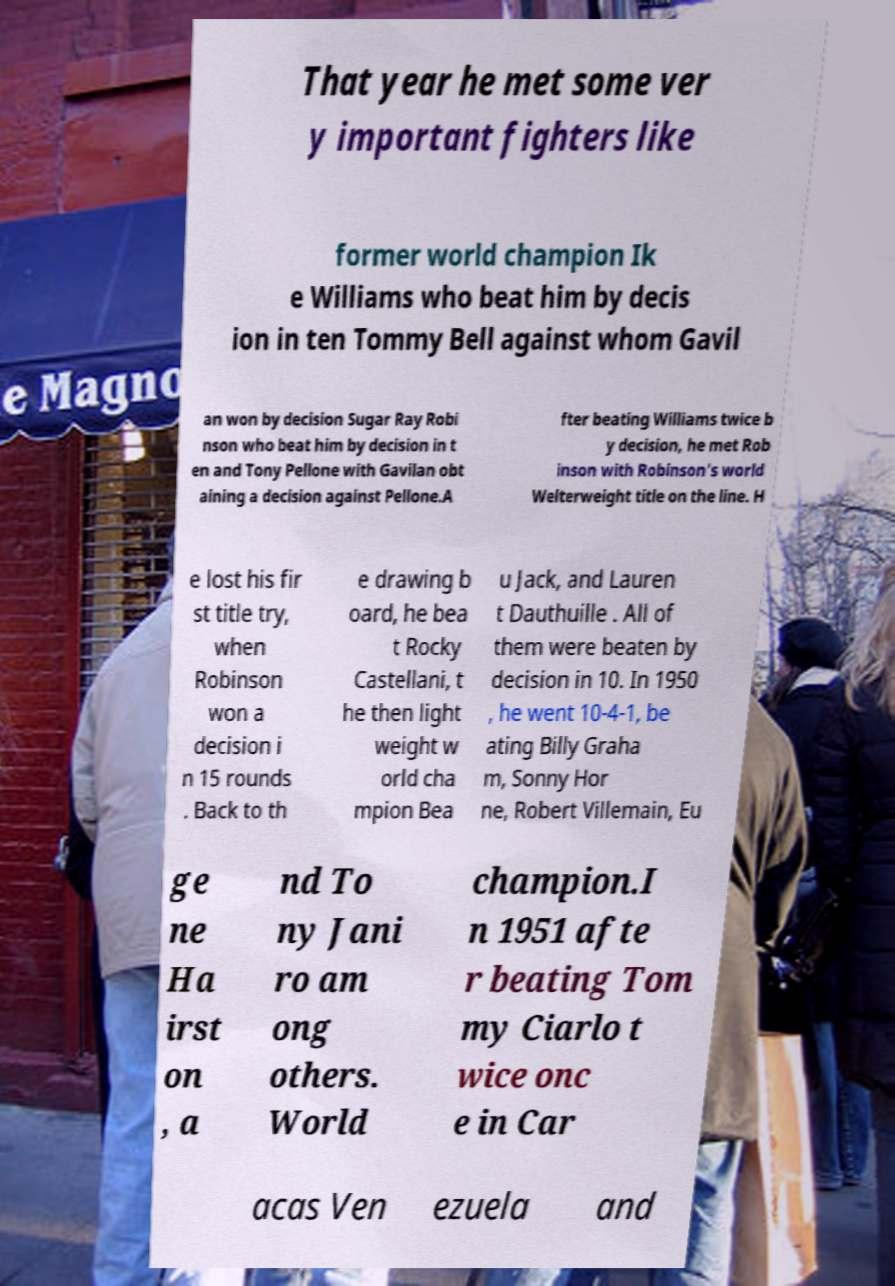Could you assist in decoding the text presented in this image and type it out clearly? That year he met some ver y important fighters like former world champion Ik e Williams who beat him by decis ion in ten Tommy Bell against whom Gavil an won by decision Sugar Ray Robi nson who beat him by decision in t en and Tony Pellone with Gavilan obt aining a decision against Pellone.A fter beating Williams twice b y decision, he met Rob inson with Robinson's world Welterweight title on the line. H e lost his fir st title try, when Robinson won a decision i n 15 rounds . Back to th e drawing b oard, he bea t Rocky Castellani, t he then light weight w orld cha mpion Bea u Jack, and Lauren t Dauthuille . All of them were beaten by decision in 10. In 1950 , he went 10-4-1, be ating Billy Graha m, Sonny Hor ne, Robert Villemain, Eu ge ne Ha irst on , a nd To ny Jani ro am ong others. World champion.I n 1951 afte r beating Tom my Ciarlo t wice onc e in Car acas Ven ezuela and 